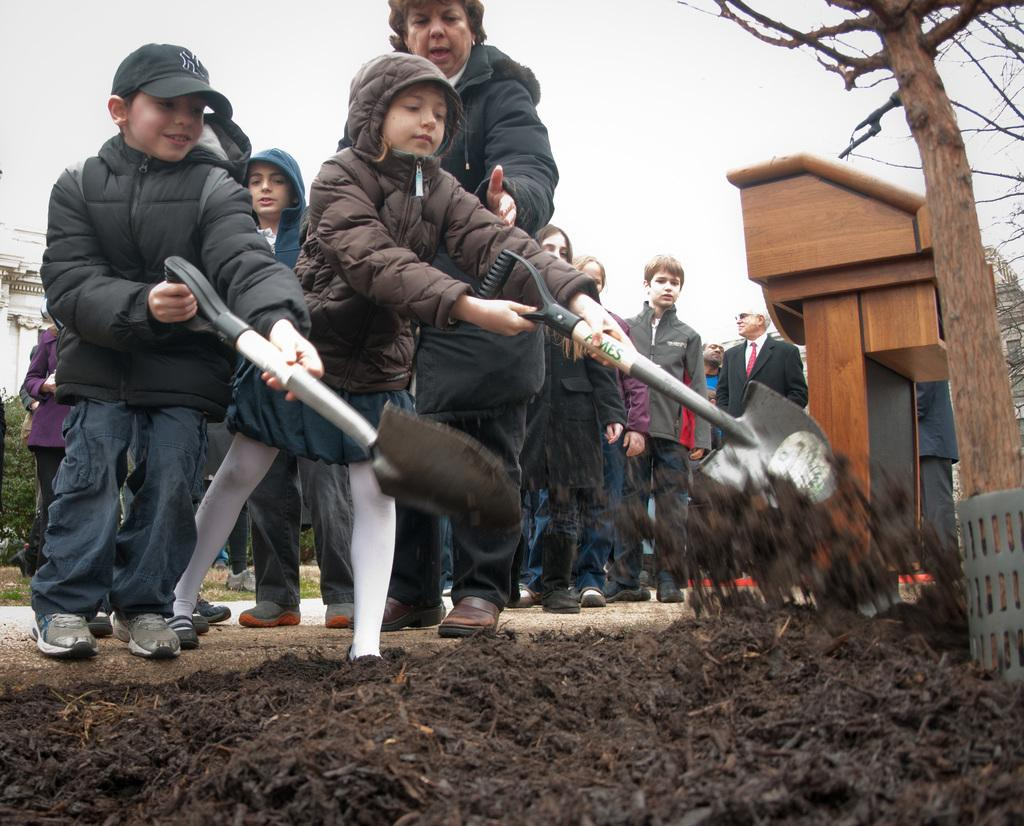Who is present in the image? There are children and people in the image. What are the children and people wearing? They are wearing hoodies. What can be seen on the right side of the image? There is a tree on the right side of the image. What is visible in the background of the image? A: The sky is visible in the background of the image. What type of animal is taking care of its territory in the image? There are no animals present in the image, and therefore no animal is taking care of its territory. How does the image demand the viewer's attention? The image does not directly demand the viewer's attention; it simply presents a scene with children, people, hoodies, a tree, and the sky. 